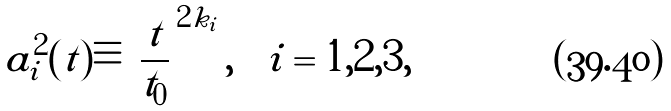Convert formula to latex. <formula><loc_0><loc_0><loc_500><loc_500>a _ { i } ^ { 2 } ( t ) \equiv \left | \frac { t } { t _ { 0 } } \right | ^ { 2 k _ { i } } , \quad i = 1 , 2 , 3 ,</formula> 